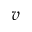<formula> <loc_0><loc_0><loc_500><loc_500>v</formula> 